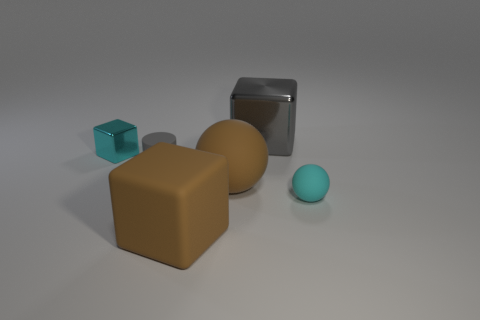Subtract all large blocks. How many blocks are left? 1 Add 3 big shiny cubes. How many objects exist? 9 Subtract 1 balls. How many balls are left? 1 Subtract all gray blocks. How many blocks are left? 2 Subtract all cylinders. How many objects are left? 5 Subtract all cyan cubes. Subtract all red spheres. How many cubes are left? 2 Add 2 large matte things. How many large matte things exist? 4 Subtract 0 brown cylinders. How many objects are left? 6 Subtract all purple cubes. How many red cylinders are left? 0 Subtract all brown objects. Subtract all large red metal cylinders. How many objects are left? 4 